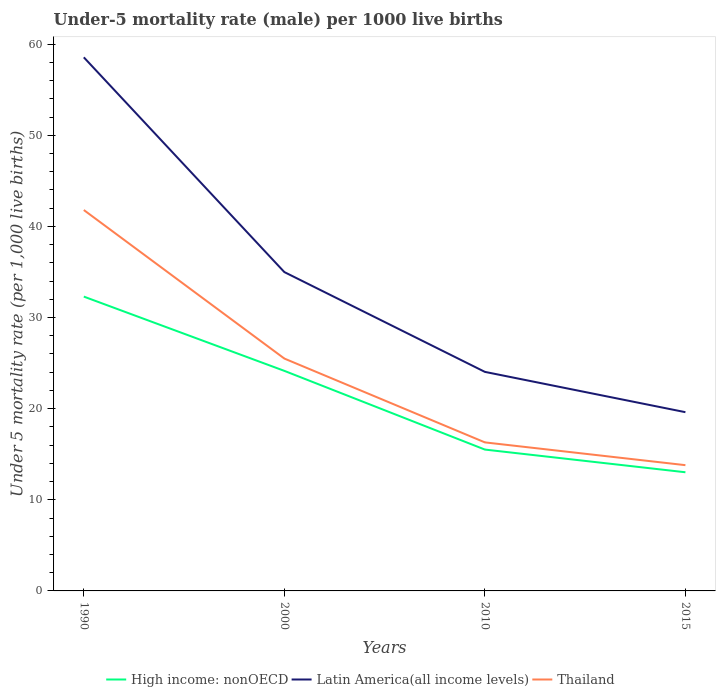Does the line corresponding to Thailand intersect with the line corresponding to Latin America(all income levels)?
Your answer should be very brief. No. Is the number of lines equal to the number of legend labels?
Keep it short and to the point. Yes. In which year was the under-five mortality rate in Thailand maximum?
Make the answer very short. 2015. What is the total under-five mortality rate in Latin America(all income levels) in the graph?
Your response must be concise. 15.37. What is the difference between the highest and the second highest under-five mortality rate in Latin America(all income levels)?
Provide a short and direct response. 38.94. What is the difference between the highest and the lowest under-five mortality rate in Latin America(all income levels)?
Provide a short and direct response. 2. Is the under-five mortality rate in High income: nonOECD strictly greater than the under-five mortality rate in Latin America(all income levels) over the years?
Make the answer very short. Yes. How many lines are there?
Make the answer very short. 3. How many years are there in the graph?
Keep it short and to the point. 4. What is the difference between two consecutive major ticks on the Y-axis?
Keep it short and to the point. 10. Are the values on the major ticks of Y-axis written in scientific E-notation?
Your answer should be compact. No. Does the graph contain any zero values?
Provide a succinct answer. No. Where does the legend appear in the graph?
Offer a very short reply. Bottom center. How are the legend labels stacked?
Your answer should be very brief. Horizontal. What is the title of the graph?
Keep it short and to the point. Under-5 mortality rate (male) per 1000 live births. What is the label or title of the X-axis?
Make the answer very short. Years. What is the label or title of the Y-axis?
Offer a terse response. Under 5 mortality rate (per 1,0 live births). What is the Under 5 mortality rate (per 1,000 live births) in High income: nonOECD in 1990?
Offer a very short reply. 32.3. What is the Under 5 mortality rate (per 1,000 live births) of Latin America(all income levels) in 1990?
Provide a succinct answer. 58.55. What is the Under 5 mortality rate (per 1,000 live births) in Thailand in 1990?
Give a very brief answer. 41.8. What is the Under 5 mortality rate (per 1,000 live births) of High income: nonOECD in 2000?
Provide a short and direct response. 24.15. What is the Under 5 mortality rate (per 1,000 live births) in Latin America(all income levels) in 2000?
Offer a terse response. 34.99. What is the Under 5 mortality rate (per 1,000 live births) of High income: nonOECD in 2010?
Make the answer very short. 15.51. What is the Under 5 mortality rate (per 1,000 live births) in Latin America(all income levels) in 2010?
Offer a very short reply. 24.04. What is the Under 5 mortality rate (per 1,000 live births) in High income: nonOECD in 2015?
Ensure brevity in your answer.  13.02. What is the Under 5 mortality rate (per 1,000 live births) in Latin America(all income levels) in 2015?
Your answer should be very brief. 19.61. Across all years, what is the maximum Under 5 mortality rate (per 1,000 live births) of High income: nonOECD?
Offer a very short reply. 32.3. Across all years, what is the maximum Under 5 mortality rate (per 1,000 live births) of Latin America(all income levels)?
Offer a terse response. 58.55. Across all years, what is the maximum Under 5 mortality rate (per 1,000 live births) in Thailand?
Offer a very short reply. 41.8. Across all years, what is the minimum Under 5 mortality rate (per 1,000 live births) in High income: nonOECD?
Ensure brevity in your answer.  13.02. Across all years, what is the minimum Under 5 mortality rate (per 1,000 live births) of Latin America(all income levels)?
Your response must be concise. 19.61. What is the total Under 5 mortality rate (per 1,000 live births) in High income: nonOECD in the graph?
Give a very brief answer. 84.98. What is the total Under 5 mortality rate (per 1,000 live births) in Latin America(all income levels) in the graph?
Offer a terse response. 137.19. What is the total Under 5 mortality rate (per 1,000 live births) in Thailand in the graph?
Offer a very short reply. 97.4. What is the difference between the Under 5 mortality rate (per 1,000 live births) of High income: nonOECD in 1990 and that in 2000?
Provide a succinct answer. 8.15. What is the difference between the Under 5 mortality rate (per 1,000 live births) of Latin America(all income levels) in 1990 and that in 2000?
Your answer should be very brief. 23.57. What is the difference between the Under 5 mortality rate (per 1,000 live births) of High income: nonOECD in 1990 and that in 2010?
Keep it short and to the point. 16.79. What is the difference between the Under 5 mortality rate (per 1,000 live births) of Latin America(all income levels) in 1990 and that in 2010?
Your answer should be compact. 34.52. What is the difference between the Under 5 mortality rate (per 1,000 live births) in Thailand in 1990 and that in 2010?
Your response must be concise. 25.5. What is the difference between the Under 5 mortality rate (per 1,000 live births) in High income: nonOECD in 1990 and that in 2015?
Provide a short and direct response. 19.28. What is the difference between the Under 5 mortality rate (per 1,000 live births) of Latin America(all income levels) in 1990 and that in 2015?
Provide a succinct answer. 38.94. What is the difference between the Under 5 mortality rate (per 1,000 live births) of Thailand in 1990 and that in 2015?
Ensure brevity in your answer.  28. What is the difference between the Under 5 mortality rate (per 1,000 live births) of High income: nonOECD in 2000 and that in 2010?
Offer a terse response. 8.64. What is the difference between the Under 5 mortality rate (per 1,000 live births) of Latin America(all income levels) in 2000 and that in 2010?
Offer a very short reply. 10.95. What is the difference between the Under 5 mortality rate (per 1,000 live births) of High income: nonOECD in 2000 and that in 2015?
Make the answer very short. 11.13. What is the difference between the Under 5 mortality rate (per 1,000 live births) of Latin America(all income levels) in 2000 and that in 2015?
Your answer should be very brief. 15.37. What is the difference between the Under 5 mortality rate (per 1,000 live births) in High income: nonOECD in 2010 and that in 2015?
Your answer should be very brief. 2.49. What is the difference between the Under 5 mortality rate (per 1,000 live births) in Latin America(all income levels) in 2010 and that in 2015?
Your answer should be compact. 4.42. What is the difference between the Under 5 mortality rate (per 1,000 live births) in Thailand in 2010 and that in 2015?
Provide a succinct answer. 2.5. What is the difference between the Under 5 mortality rate (per 1,000 live births) of High income: nonOECD in 1990 and the Under 5 mortality rate (per 1,000 live births) of Latin America(all income levels) in 2000?
Provide a short and direct response. -2.69. What is the difference between the Under 5 mortality rate (per 1,000 live births) in High income: nonOECD in 1990 and the Under 5 mortality rate (per 1,000 live births) in Thailand in 2000?
Keep it short and to the point. 6.8. What is the difference between the Under 5 mortality rate (per 1,000 live births) in Latin America(all income levels) in 1990 and the Under 5 mortality rate (per 1,000 live births) in Thailand in 2000?
Offer a very short reply. 33.05. What is the difference between the Under 5 mortality rate (per 1,000 live births) of High income: nonOECD in 1990 and the Under 5 mortality rate (per 1,000 live births) of Latin America(all income levels) in 2010?
Your answer should be very brief. 8.26. What is the difference between the Under 5 mortality rate (per 1,000 live births) of High income: nonOECD in 1990 and the Under 5 mortality rate (per 1,000 live births) of Thailand in 2010?
Provide a succinct answer. 16. What is the difference between the Under 5 mortality rate (per 1,000 live births) in Latin America(all income levels) in 1990 and the Under 5 mortality rate (per 1,000 live births) in Thailand in 2010?
Keep it short and to the point. 42.25. What is the difference between the Under 5 mortality rate (per 1,000 live births) of High income: nonOECD in 1990 and the Under 5 mortality rate (per 1,000 live births) of Latin America(all income levels) in 2015?
Ensure brevity in your answer.  12.68. What is the difference between the Under 5 mortality rate (per 1,000 live births) in High income: nonOECD in 1990 and the Under 5 mortality rate (per 1,000 live births) in Thailand in 2015?
Your answer should be very brief. 18.5. What is the difference between the Under 5 mortality rate (per 1,000 live births) of Latin America(all income levels) in 1990 and the Under 5 mortality rate (per 1,000 live births) of Thailand in 2015?
Ensure brevity in your answer.  44.75. What is the difference between the Under 5 mortality rate (per 1,000 live births) in High income: nonOECD in 2000 and the Under 5 mortality rate (per 1,000 live births) in Latin America(all income levels) in 2010?
Provide a succinct answer. 0.11. What is the difference between the Under 5 mortality rate (per 1,000 live births) of High income: nonOECD in 2000 and the Under 5 mortality rate (per 1,000 live births) of Thailand in 2010?
Your answer should be compact. 7.85. What is the difference between the Under 5 mortality rate (per 1,000 live births) in Latin America(all income levels) in 2000 and the Under 5 mortality rate (per 1,000 live births) in Thailand in 2010?
Your answer should be very brief. 18.69. What is the difference between the Under 5 mortality rate (per 1,000 live births) in High income: nonOECD in 2000 and the Under 5 mortality rate (per 1,000 live births) in Latin America(all income levels) in 2015?
Offer a very short reply. 4.53. What is the difference between the Under 5 mortality rate (per 1,000 live births) in High income: nonOECD in 2000 and the Under 5 mortality rate (per 1,000 live births) in Thailand in 2015?
Ensure brevity in your answer.  10.35. What is the difference between the Under 5 mortality rate (per 1,000 live births) of Latin America(all income levels) in 2000 and the Under 5 mortality rate (per 1,000 live births) of Thailand in 2015?
Keep it short and to the point. 21.19. What is the difference between the Under 5 mortality rate (per 1,000 live births) in High income: nonOECD in 2010 and the Under 5 mortality rate (per 1,000 live births) in Latin America(all income levels) in 2015?
Your answer should be very brief. -4.1. What is the difference between the Under 5 mortality rate (per 1,000 live births) of High income: nonOECD in 2010 and the Under 5 mortality rate (per 1,000 live births) of Thailand in 2015?
Keep it short and to the point. 1.71. What is the difference between the Under 5 mortality rate (per 1,000 live births) of Latin America(all income levels) in 2010 and the Under 5 mortality rate (per 1,000 live births) of Thailand in 2015?
Offer a very short reply. 10.24. What is the average Under 5 mortality rate (per 1,000 live births) in High income: nonOECD per year?
Ensure brevity in your answer.  21.25. What is the average Under 5 mortality rate (per 1,000 live births) in Latin America(all income levels) per year?
Offer a very short reply. 34.3. What is the average Under 5 mortality rate (per 1,000 live births) in Thailand per year?
Offer a very short reply. 24.35. In the year 1990, what is the difference between the Under 5 mortality rate (per 1,000 live births) in High income: nonOECD and Under 5 mortality rate (per 1,000 live births) in Latin America(all income levels)?
Ensure brevity in your answer.  -26.26. In the year 1990, what is the difference between the Under 5 mortality rate (per 1,000 live births) of High income: nonOECD and Under 5 mortality rate (per 1,000 live births) of Thailand?
Offer a very short reply. -9.5. In the year 1990, what is the difference between the Under 5 mortality rate (per 1,000 live births) of Latin America(all income levels) and Under 5 mortality rate (per 1,000 live births) of Thailand?
Your answer should be very brief. 16.75. In the year 2000, what is the difference between the Under 5 mortality rate (per 1,000 live births) in High income: nonOECD and Under 5 mortality rate (per 1,000 live births) in Latin America(all income levels)?
Your answer should be very brief. -10.84. In the year 2000, what is the difference between the Under 5 mortality rate (per 1,000 live births) in High income: nonOECD and Under 5 mortality rate (per 1,000 live births) in Thailand?
Keep it short and to the point. -1.35. In the year 2000, what is the difference between the Under 5 mortality rate (per 1,000 live births) in Latin America(all income levels) and Under 5 mortality rate (per 1,000 live births) in Thailand?
Give a very brief answer. 9.49. In the year 2010, what is the difference between the Under 5 mortality rate (per 1,000 live births) in High income: nonOECD and Under 5 mortality rate (per 1,000 live births) in Latin America(all income levels)?
Your answer should be compact. -8.53. In the year 2010, what is the difference between the Under 5 mortality rate (per 1,000 live births) in High income: nonOECD and Under 5 mortality rate (per 1,000 live births) in Thailand?
Offer a terse response. -0.79. In the year 2010, what is the difference between the Under 5 mortality rate (per 1,000 live births) of Latin America(all income levels) and Under 5 mortality rate (per 1,000 live births) of Thailand?
Your answer should be very brief. 7.74. In the year 2015, what is the difference between the Under 5 mortality rate (per 1,000 live births) of High income: nonOECD and Under 5 mortality rate (per 1,000 live births) of Latin America(all income levels)?
Provide a succinct answer. -6.59. In the year 2015, what is the difference between the Under 5 mortality rate (per 1,000 live births) in High income: nonOECD and Under 5 mortality rate (per 1,000 live births) in Thailand?
Provide a succinct answer. -0.78. In the year 2015, what is the difference between the Under 5 mortality rate (per 1,000 live births) in Latin America(all income levels) and Under 5 mortality rate (per 1,000 live births) in Thailand?
Your answer should be compact. 5.81. What is the ratio of the Under 5 mortality rate (per 1,000 live births) in High income: nonOECD in 1990 to that in 2000?
Your answer should be compact. 1.34. What is the ratio of the Under 5 mortality rate (per 1,000 live births) of Latin America(all income levels) in 1990 to that in 2000?
Ensure brevity in your answer.  1.67. What is the ratio of the Under 5 mortality rate (per 1,000 live births) of Thailand in 1990 to that in 2000?
Your answer should be very brief. 1.64. What is the ratio of the Under 5 mortality rate (per 1,000 live births) of High income: nonOECD in 1990 to that in 2010?
Provide a short and direct response. 2.08. What is the ratio of the Under 5 mortality rate (per 1,000 live births) in Latin America(all income levels) in 1990 to that in 2010?
Offer a very short reply. 2.44. What is the ratio of the Under 5 mortality rate (per 1,000 live births) in Thailand in 1990 to that in 2010?
Provide a succinct answer. 2.56. What is the ratio of the Under 5 mortality rate (per 1,000 live births) in High income: nonOECD in 1990 to that in 2015?
Make the answer very short. 2.48. What is the ratio of the Under 5 mortality rate (per 1,000 live births) in Latin America(all income levels) in 1990 to that in 2015?
Make the answer very short. 2.99. What is the ratio of the Under 5 mortality rate (per 1,000 live births) of Thailand in 1990 to that in 2015?
Give a very brief answer. 3.03. What is the ratio of the Under 5 mortality rate (per 1,000 live births) of High income: nonOECD in 2000 to that in 2010?
Provide a short and direct response. 1.56. What is the ratio of the Under 5 mortality rate (per 1,000 live births) of Latin America(all income levels) in 2000 to that in 2010?
Provide a short and direct response. 1.46. What is the ratio of the Under 5 mortality rate (per 1,000 live births) in Thailand in 2000 to that in 2010?
Make the answer very short. 1.56. What is the ratio of the Under 5 mortality rate (per 1,000 live births) in High income: nonOECD in 2000 to that in 2015?
Offer a very short reply. 1.85. What is the ratio of the Under 5 mortality rate (per 1,000 live births) in Latin America(all income levels) in 2000 to that in 2015?
Ensure brevity in your answer.  1.78. What is the ratio of the Under 5 mortality rate (per 1,000 live births) of Thailand in 2000 to that in 2015?
Your response must be concise. 1.85. What is the ratio of the Under 5 mortality rate (per 1,000 live births) in High income: nonOECD in 2010 to that in 2015?
Give a very brief answer. 1.19. What is the ratio of the Under 5 mortality rate (per 1,000 live births) in Latin America(all income levels) in 2010 to that in 2015?
Offer a very short reply. 1.23. What is the ratio of the Under 5 mortality rate (per 1,000 live births) of Thailand in 2010 to that in 2015?
Provide a short and direct response. 1.18. What is the difference between the highest and the second highest Under 5 mortality rate (per 1,000 live births) in High income: nonOECD?
Your answer should be very brief. 8.15. What is the difference between the highest and the second highest Under 5 mortality rate (per 1,000 live births) of Latin America(all income levels)?
Provide a short and direct response. 23.57. What is the difference between the highest and the second highest Under 5 mortality rate (per 1,000 live births) of Thailand?
Your response must be concise. 16.3. What is the difference between the highest and the lowest Under 5 mortality rate (per 1,000 live births) of High income: nonOECD?
Your response must be concise. 19.28. What is the difference between the highest and the lowest Under 5 mortality rate (per 1,000 live births) in Latin America(all income levels)?
Keep it short and to the point. 38.94. What is the difference between the highest and the lowest Under 5 mortality rate (per 1,000 live births) of Thailand?
Offer a very short reply. 28. 